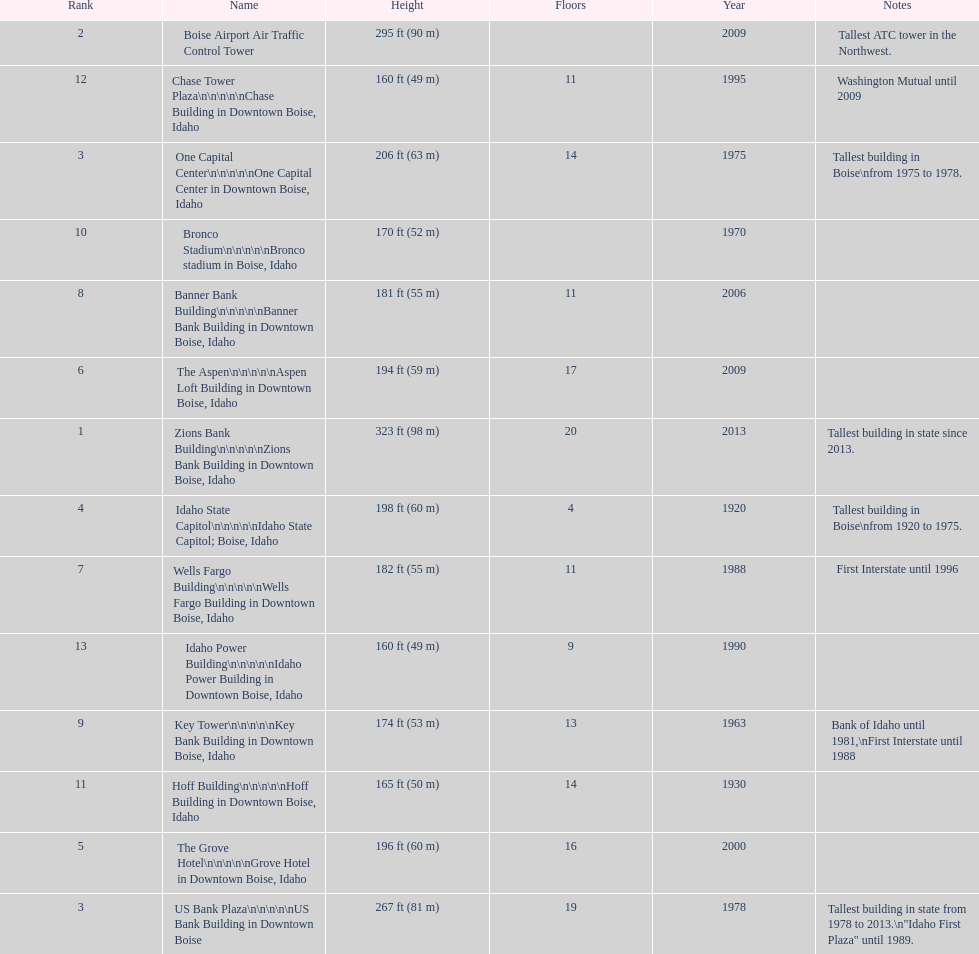What is the most elevated edifice in boise, idaho? Zions Bank Building Zions Bank Building in Downtown Boise, Idaho. 